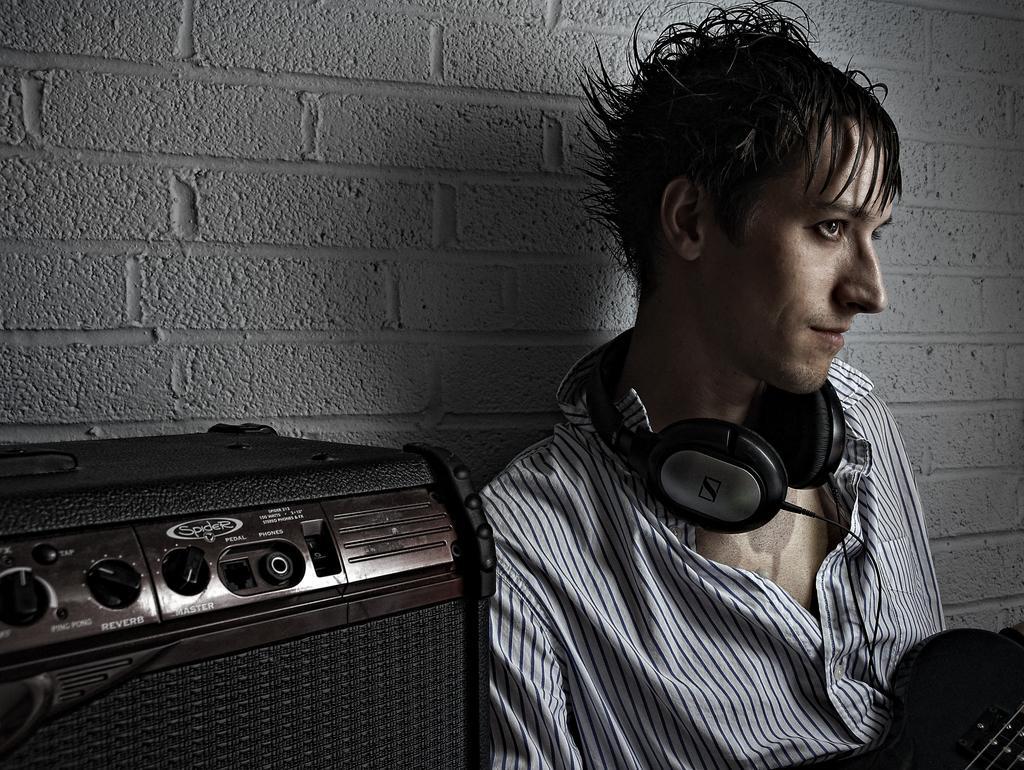Can you describe this image briefly? In the picture we can see a man sitting near the wall, leaning into it and he is with a headset on his neck and he is with funky hair style and beside him we can see a box which is black in color with some buttons to it. 